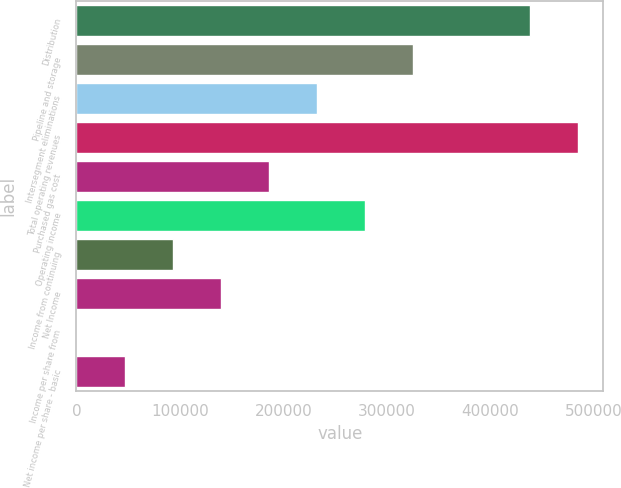<chart> <loc_0><loc_0><loc_500><loc_500><bar_chart><fcel>Distribution<fcel>Pipeline and storage<fcel>Intersegment eliminations<fcel>Total operating revenues<fcel>Purchased gas cost<fcel>Operating income<fcel>Income from continuing<fcel>Net Income<fcel>Income per share from<fcel>Net income per share - basic<nl><fcel>437918<fcel>325416<fcel>232440<fcel>484406<fcel>185952<fcel>278928<fcel>92976.3<fcel>139464<fcel>0.34<fcel>46488.3<nl></chart> 